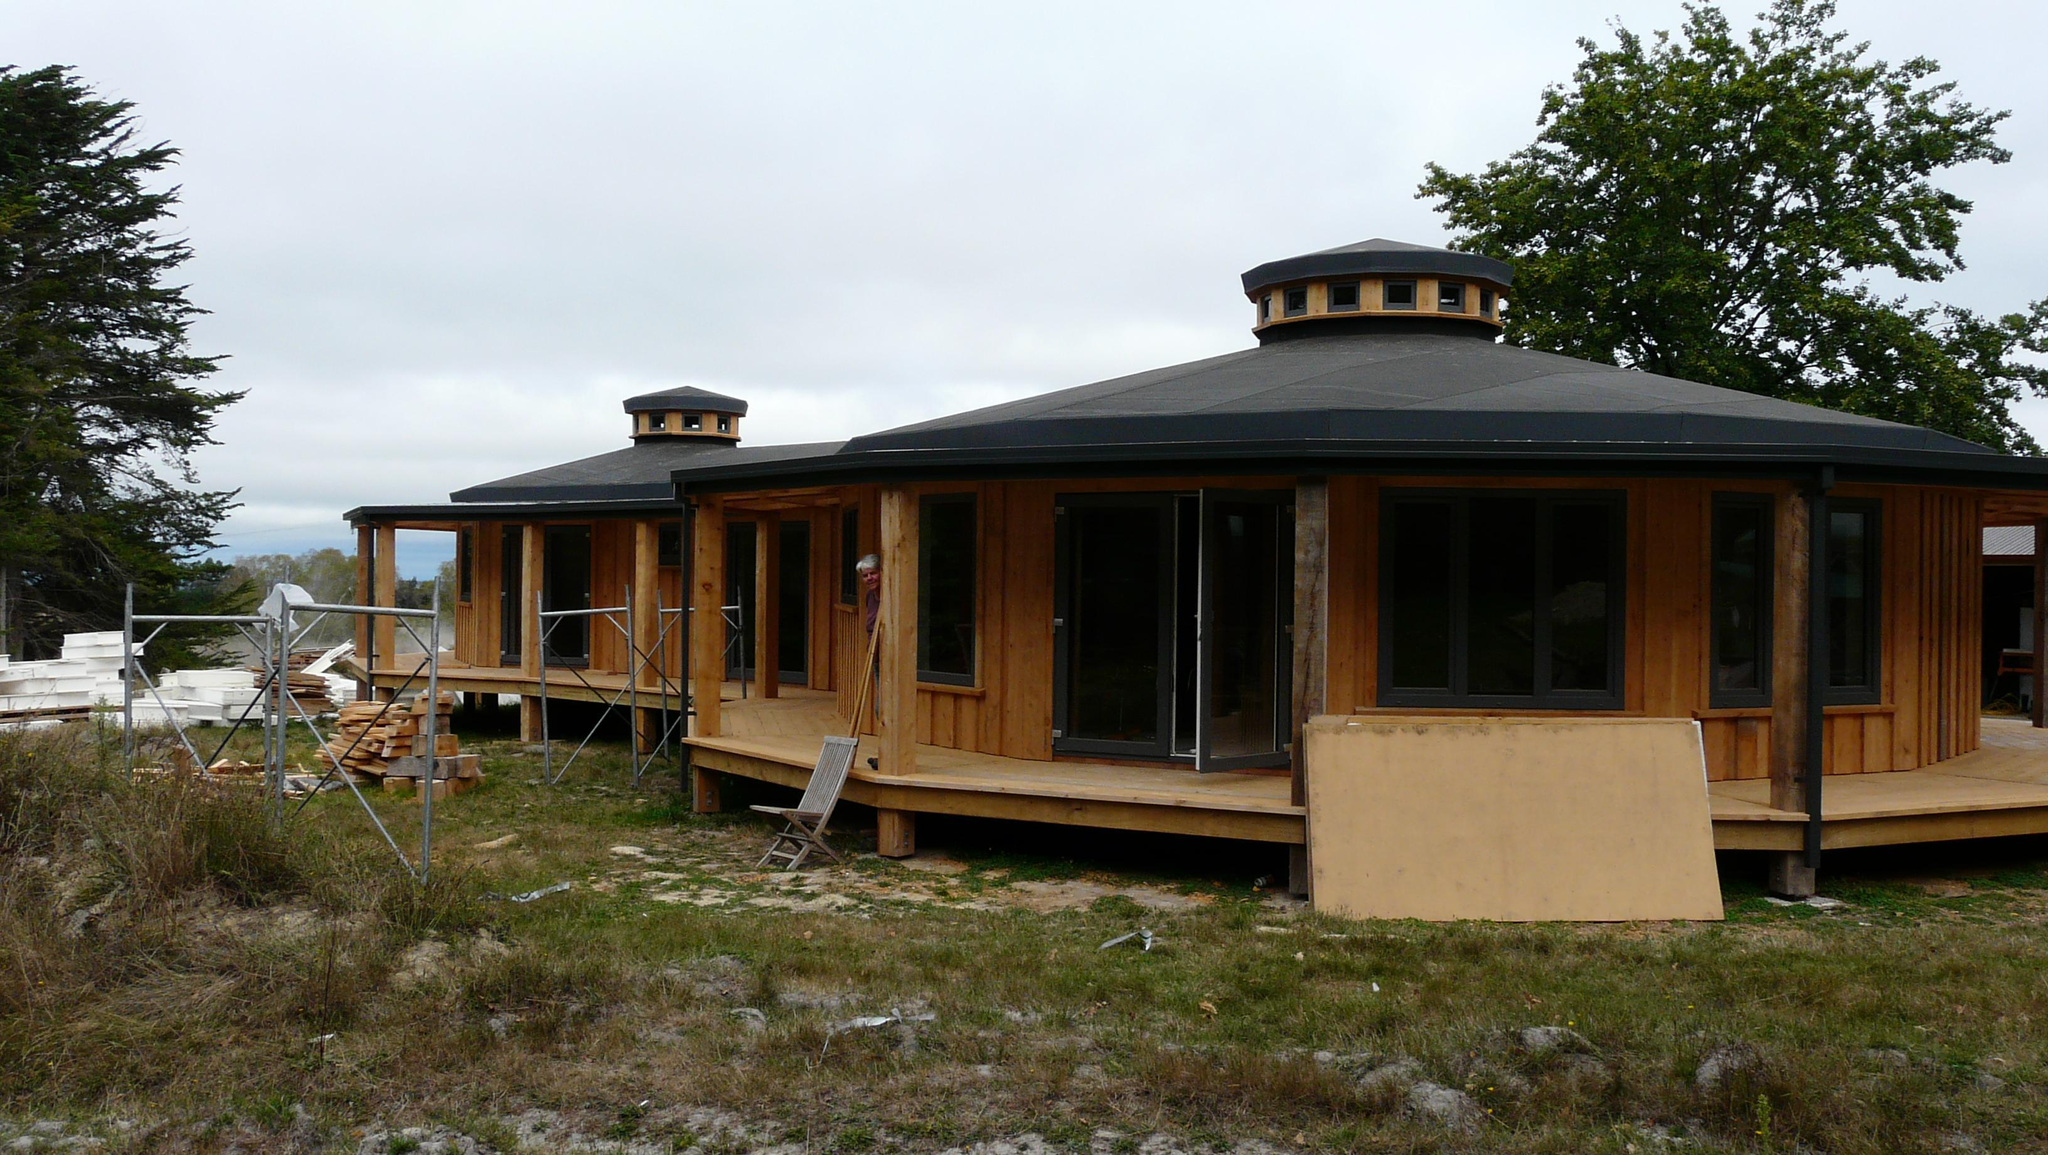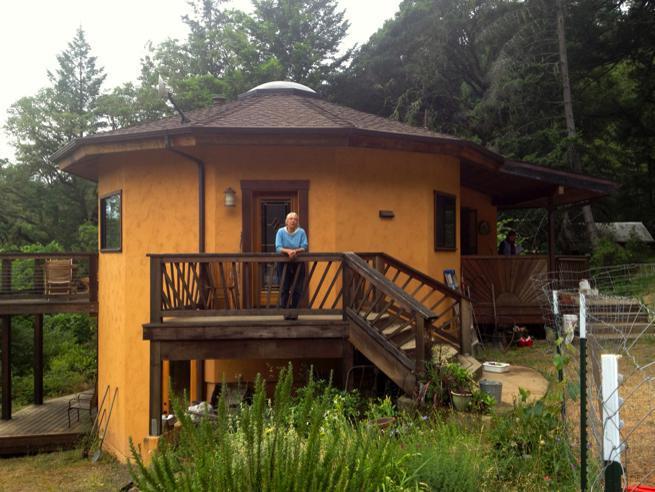The first image is the image on the left, the second image is the image on the right. For the images displayed, is the sentence "The building in the picture on the left is painted red." factually correct? Answer yes or no. No. 